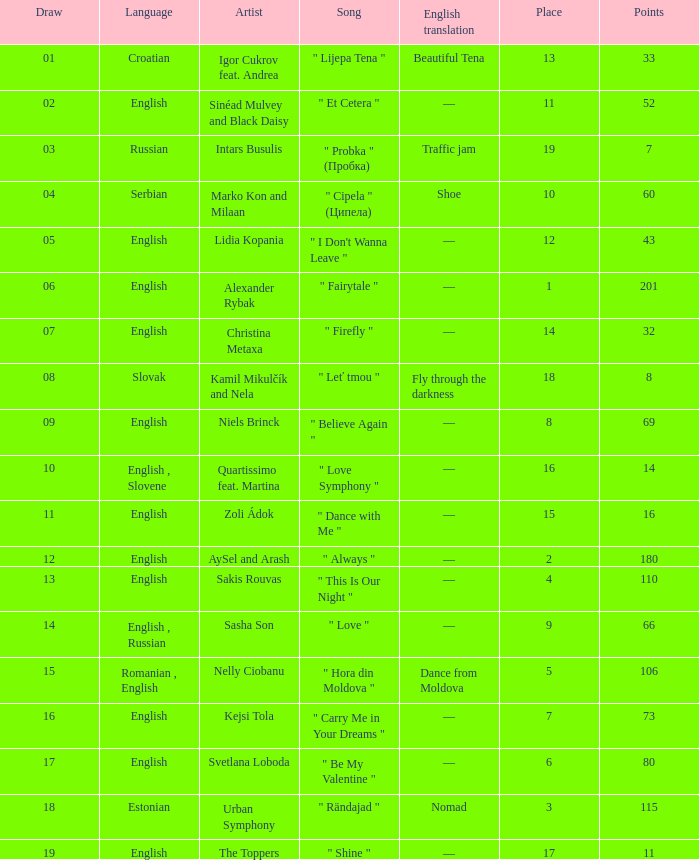What is the place when the draw is less than 12 and the artist is quartissimo feat. martina? 16.0. 